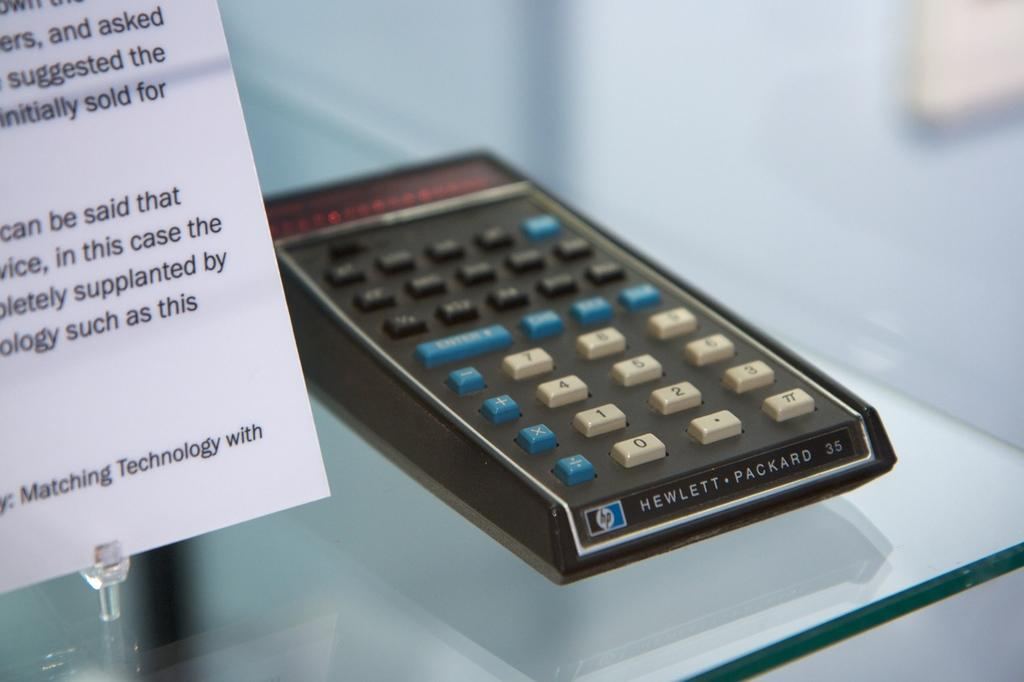<image>
Provide a brief description of the given image. An HP calculator with blue, black and white buttons is on display. 